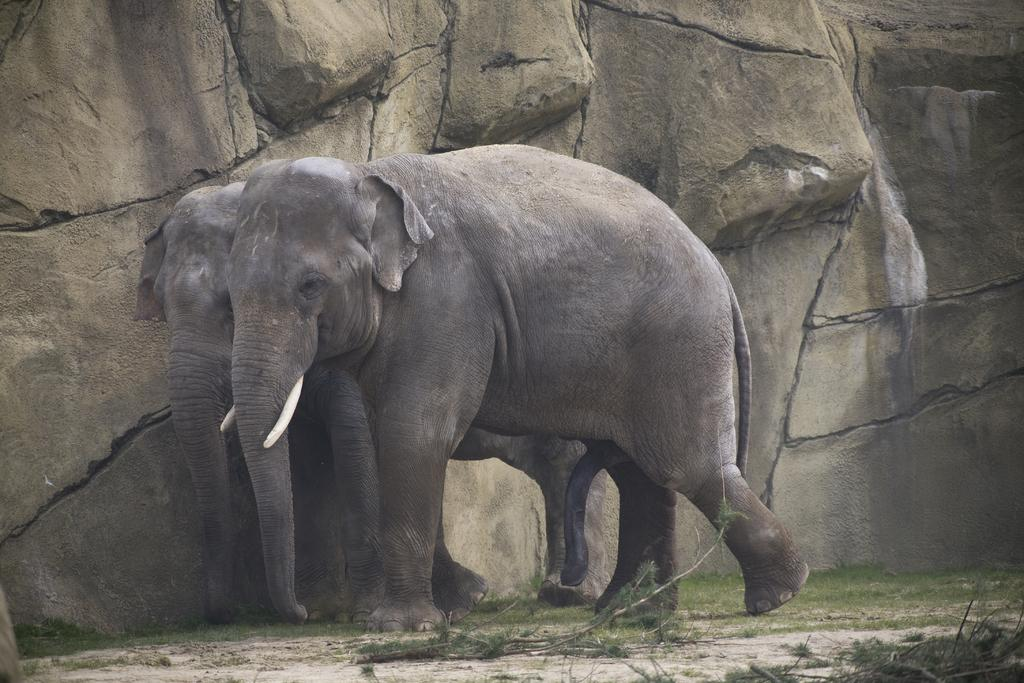What animals are present in the image? There are two elephants in the image. Where are the elephants located in the image? The elephants are in the middle of the image. What can be seen in the background of the image? There is a rock in the background of the image. Can you hear the steam whistling from the elephants in the image? There is no steam or whistling present in the image; it features two elephants in the middle of the image with a rock in the background. 